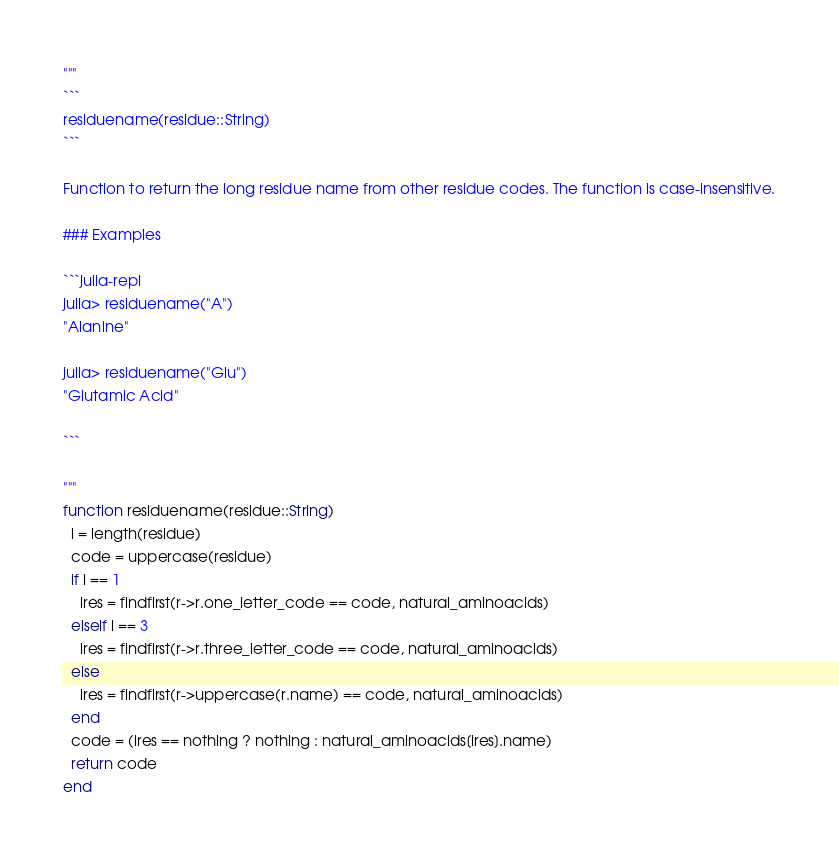Convert code to text. <code><loc_0><loc_0><loc_500><loc_500><_Julia_>"""
```
residuename(residue::String)
```

Function to return the long residue name from other residue codes. The function is case-insensitive.

### Examples

```julia-repl
julia> residuename("A")
"Alanine"

julia> residuename("Glu")
"Glutamic Acid"

```

"""
function residuename(residue::String)
  l = length(residue)
  code = uppercase(residue)
  if l == 1
    ires = findfirst(r->r.one_letter_code == code, natural_aminoacids)
  elseif l == 3
    ires = findfirst(r->r.three_letter_code == code, natural_aminoacids)
  else
    ires = findfirst(r->uppercase(r.name) == code, natural_aminoacids)
  end
  code = (ires == nothing ? nothing : natural_aminoacids[ires].name)
  return code
end

</code> 